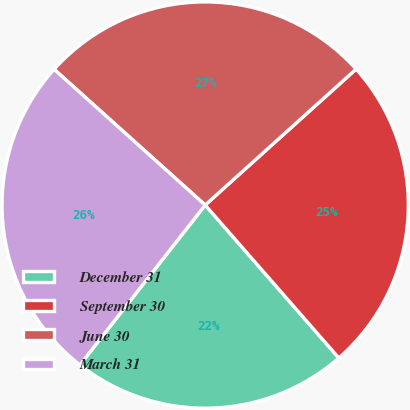Convert chart. <chart><loc_0><loc_0><loc_500><loc_500><pie_chart><fcel>December 31<fcel>September 30<fcel>June 30<fcel>March 31<nl><fcel>22.01%<fcel>25.24%<fcel>26.68%<fcel>26.07%<nl></chart> 